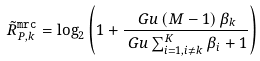<formula> <loc_0><loc_0><loc_500><loc_500>\tilde { R } _ { P , k } ^ { \tt { m r c } } & = \log _ { 2 } \left ( 1 + \frac { \ G u \left ( M - 1 \right ) \beta _ { k } } { \ G u \sum _ { i = 1 , i \neq k } ^ { K } \beta _ { i } + 1 } \right )</formula> 